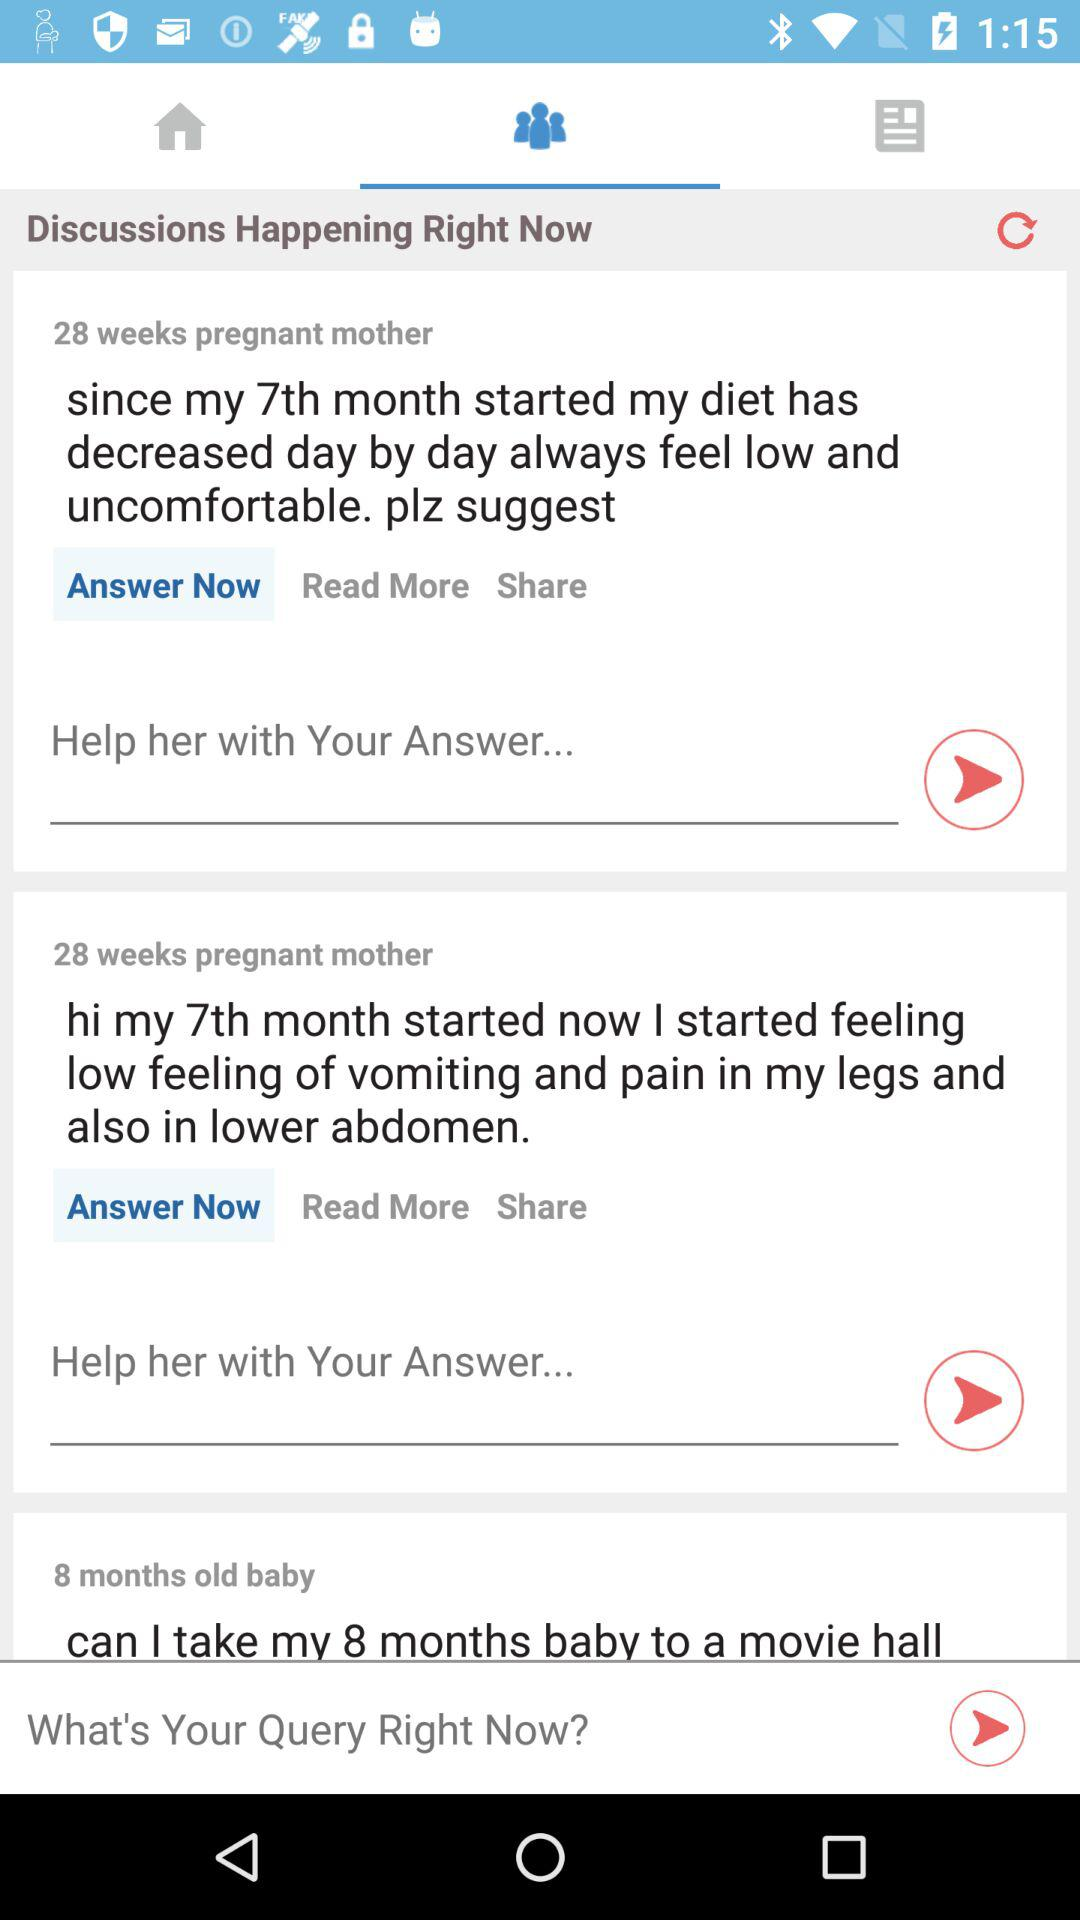What is the age of the baby going to a movie? The age of the baby is 8 months. 